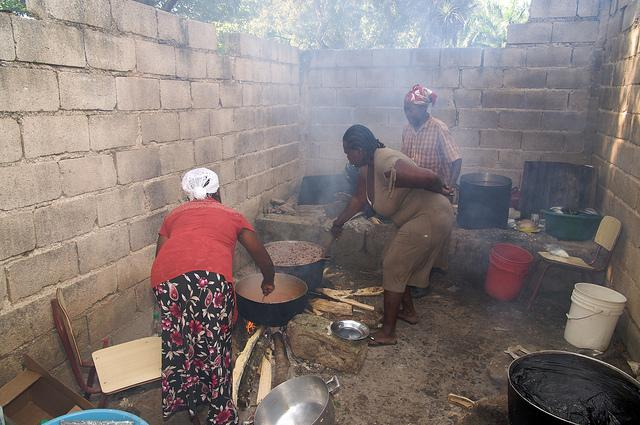What are the women doing over the large containers on the ground? Please explain your reasoning. cooking. Woman are standing over large pots with spoons in their hands and the pots are steaming. 